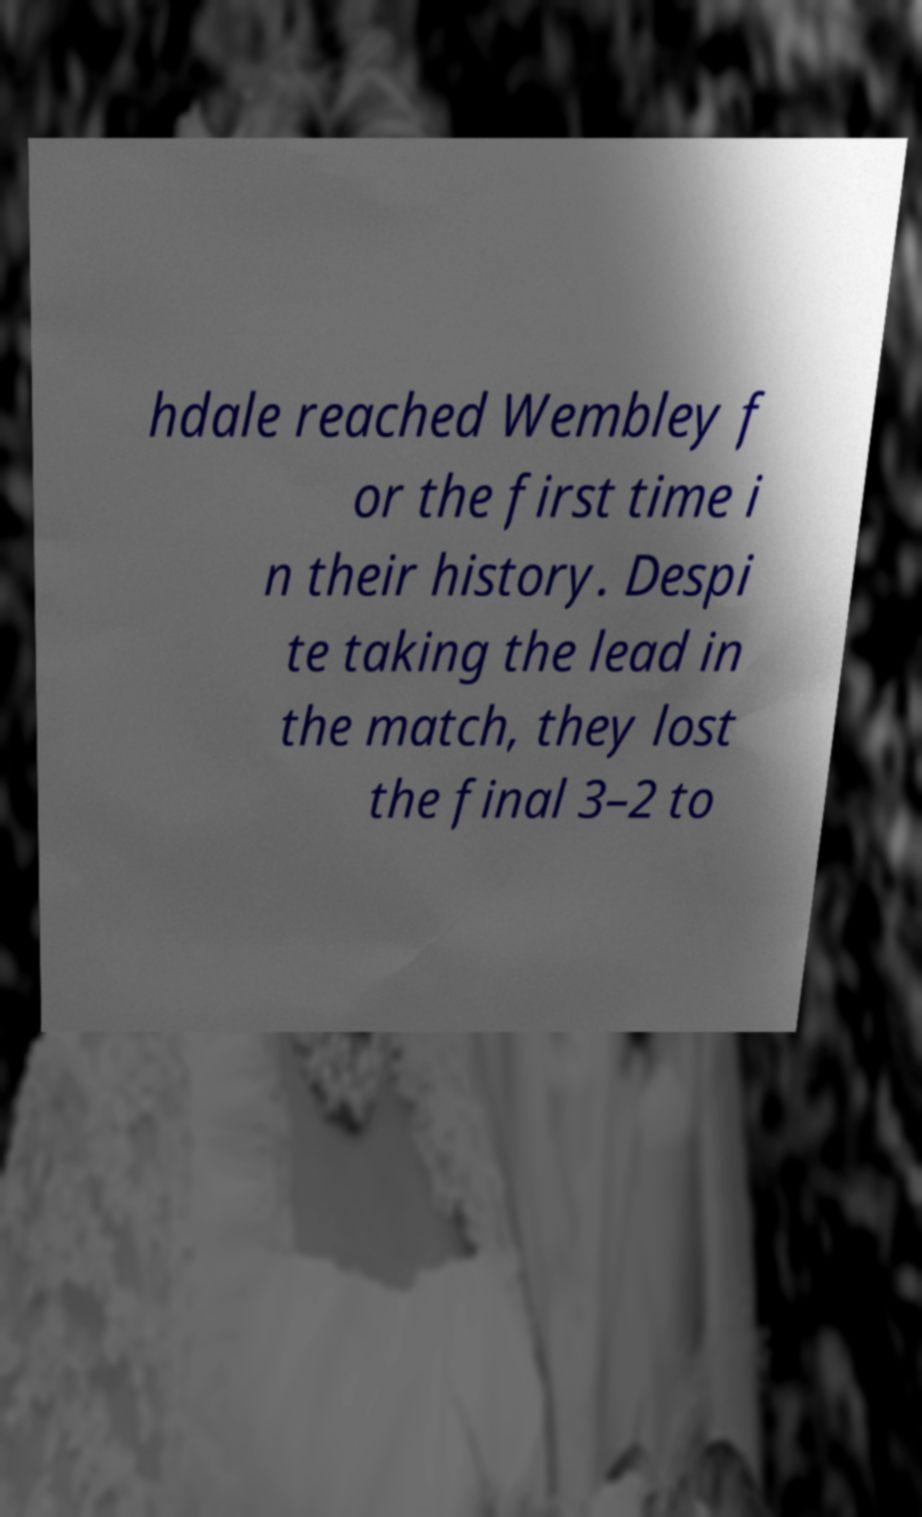There's text embedded in this image that I need extracted. Can you transcribe it verbatim? hdale reached Wembley f or the first time i n their history. Despi te taking the lead in the match, they lost the final 3–2 to 